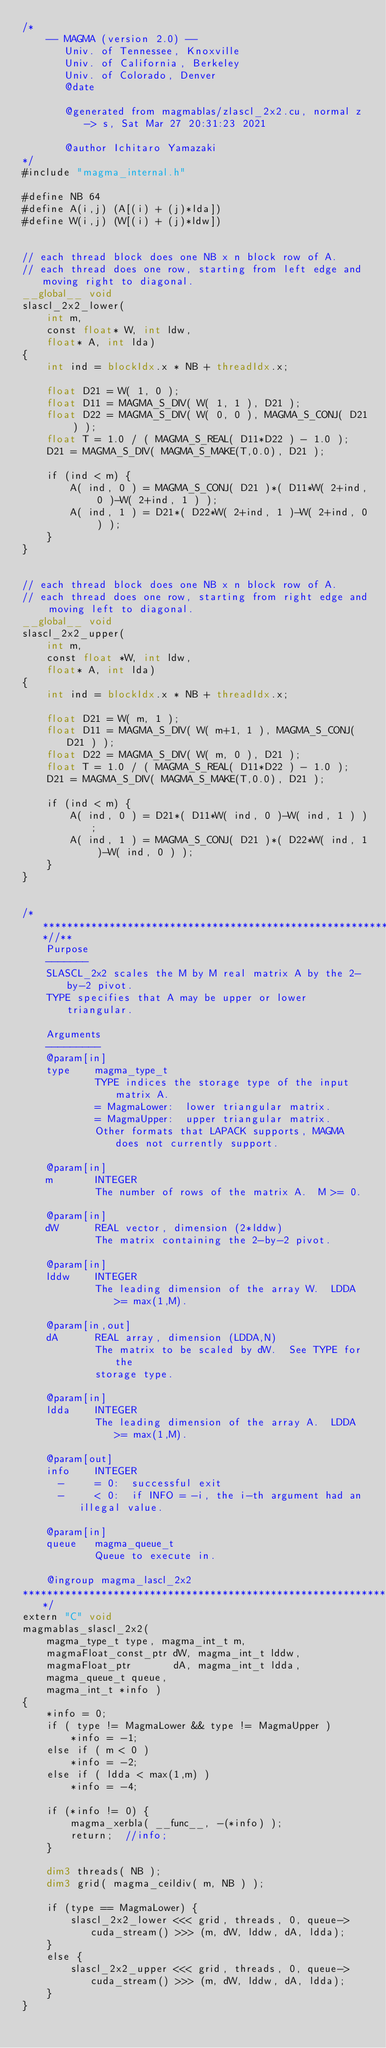Convert code to text. <code><loc_0><loc_0><loc_500><loc_500><_Cuda_>/*
    -- MAGMA (version 2.0) --
       Univ. of Tennessee, Knoxville
       Univ. of California, Berkeley
       Univ. of Colorado, Denver
       @date

       @generated from magmablas/zlascl_2x2.cu, normal z -> s, Sat Mar 27 20:31:23 2021

       @author Ichitaro Yamazaki
*/
#include "magma_internal.h"

#define NB 64
#define A(i,j) (A[(i) + (j)*lda])
#define W(i,j) (W[(i) + (j)*ldw])


// each thread block does one NB x n block row of A.
// each thread does one row, starting from left edge and moving right to diagonal.
__global__ void
slascl_2x2_lower(
    int m,
    const float* W, int ldw,
    float* A, int lda)
{
    int ind = blockIdx.x * NB + threadIdx.x;

    float D21 = W( 1, 0 );
    float D11 = MAGMA_S_DIV( W( 1, 1 ), D21 );
    float D22 = MAGMA_S_DIV( W( 0, 0 ), MAGMA_S_CONJ( D21 ) );
    float T = 1.0 / ( MAGMA_S_REAL( D11*D22 ) - 1.0 );
    D21 = MAGMA_S_DIV( MAGMA_S_MAKE(T,0.0), D21 );

    if (ind < m) {
        A( ind, 0 ) = MAGMA_S_CONJ( D21 )*( D11*W( 2+ind, 0 )-W( 2+ind, 1 ) );
        A( ind, 1 ) = D21*( D22*W( 2+ind, 1 )-W( 2+ind, 0 ) );
    }
}


// each thread block does one NB x n block row of A.
// each thread does one row, starting from right edge and moving left to diagonal.
__global__ void
slascl_2x2_upper(
    int m,
    const float *W, int ldw,
    float* A, int lda)
{
    int ind = blockIdx.x * NB + threadIdx.x;

    float D21 = W( m, 1 );
    float D11 = MAGMA_S_DIV( W( m+1, 1 ), MAGMA_S_CONJ( D21 ) );
    float D22 = MAGMA_S_DIV( W( m, 0 ), D21 );
    float T = 1.0 / ( MAGMA_S_REAL( D11*D22 ) - 1.0 );
    D21 = MAGMA_S_DIV( MAGMA_S_MAKE(T,0.0), D21 );

    if (ind < m) {
        A( ind, 0 ) = D21*( D11*W( ind, 0 )-W( ind, 1 ) );
        A( ind, 1 ) = MAGMA_S_CONJ( D21 )*( D22*W( ind, 1 )-W( ind, 0 ) );
    }
}


/***************************************************************************//**
    Purpose
    -------
    SLASCL_2x2 scales the M by M real matrix A by the 2-by-2 pivot.
    TYPE specifies that A may be upper or lower triangular.

    Arguments
    ---------
    @param[in]
    type    magma_type_t
            TYPE indices the storage type of the input matrix A.
            = MagmaLower:  lower triangular matrix.
            = MagmaUpper:  upper triangular matrix.
            Other formats that LAPACK supports, MAGMA does not currently support.

    @param[in]
    m       INTEGER
            The number of rows of the matrix A.  M >= 0.

    @param[in]
    dW      REAL vector, dimension (2*lddw)
            The matrix containing the 2-by-2 pivot.

    @param[in]
    lddw    INTEGER
            The leading dimension of the array W.  LDDA >= max(1,M).

    @param[in,out]
    dA      REAL array, dimension (LDDA,N)
            The matrix to be scaled by dW.  See TYPE for the
            storage type.

    @param[in]
    ldda    INTEGER
            The leading dimension of the array A.  LDDA >= max(1,M).

    @param[out]
    info    INTEGER
      -     = 0:  successful exit
      -     < 0:  if INFO = -i, the i-th argument had an illegal value.

    @param[in]
    queue   magma_queue_t
            Queue to execute in.

    @ingroup magma_lascl_2x2
*******************************************************************************/
extern "C" void
magmablas_slascl_2x2(
    magma_type_t type, magma_int_t m,
    magmaFloat_const_ptr dW, magma_int_t lddw,
    magmaFloat_ptr       dA, magma_int_t ldda,
    magma_queue_t queue,
    magma_int_t *info )
{
    *info = 0;
    if ( type != MagmaLower && type != MagmaUpper )
        *info = -1;
    else if ( m < 0 )
        *info = -2;
    else if ( ldda < max(1,m) )
        *info = -4;
    
    if (*info != 0) {
        magma_xerbla( __func__, -(*info) );
        return;  //info;
    }
    
    dim3 threads( NB );
    dim3 grid( magma_ceildiv( m, NB ) );
    
    if (type == MagmaLower) {
        slascl_2x2_lower <<< grid, threads, 0, queue->cuda_stream() >>> (m, dW, lddw, dA, ldda);
    }
    else {
        slascl_2x2_upper <<< grid, threads, 0, queue->cuda_stream() >>> (m, dW, lddw, dA, ldda);
    }
}
</code> 